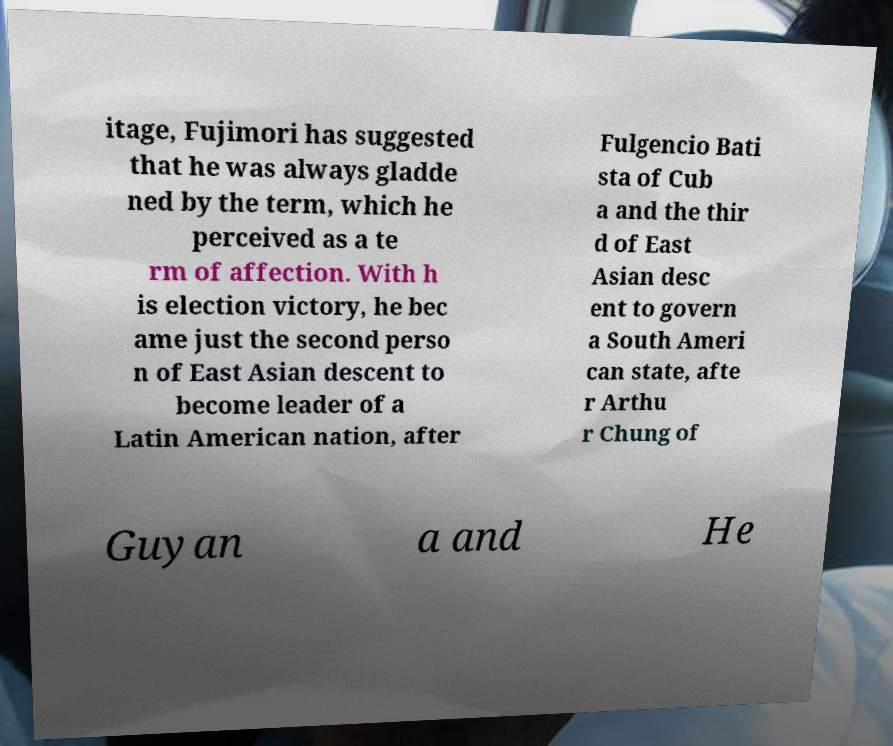For documentation purposes, I need the text within this image transcribed. Could you provide that? itage, Fujimori has suggested that he was always gladde ned by the term, which he perceived as a te rm of affection. With h is election victory, he bec ame just the second perso n of East Asian descent to become leader of a Latin American nation, after Fulgencio Bati sta of Cub a and the thir d of East Asian desc ent to govern a South Ameri can state, afte r Arthu r Chung of Guyan a and He 